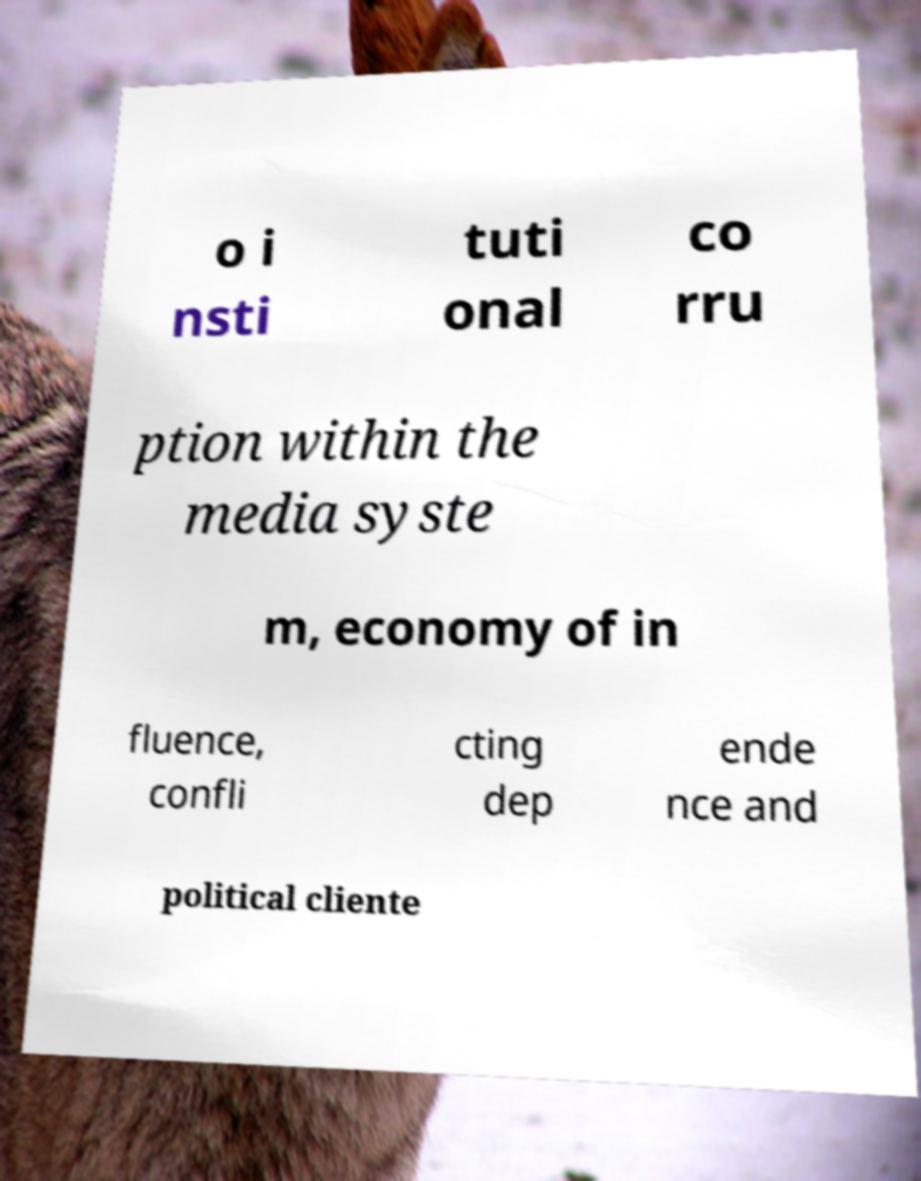I need the written content from this picture converted into text. Can you do that? o i nsti tuti onal co rru ption within the media syste m, economy of in fluence, confli cting dep ende nce and political cliente 